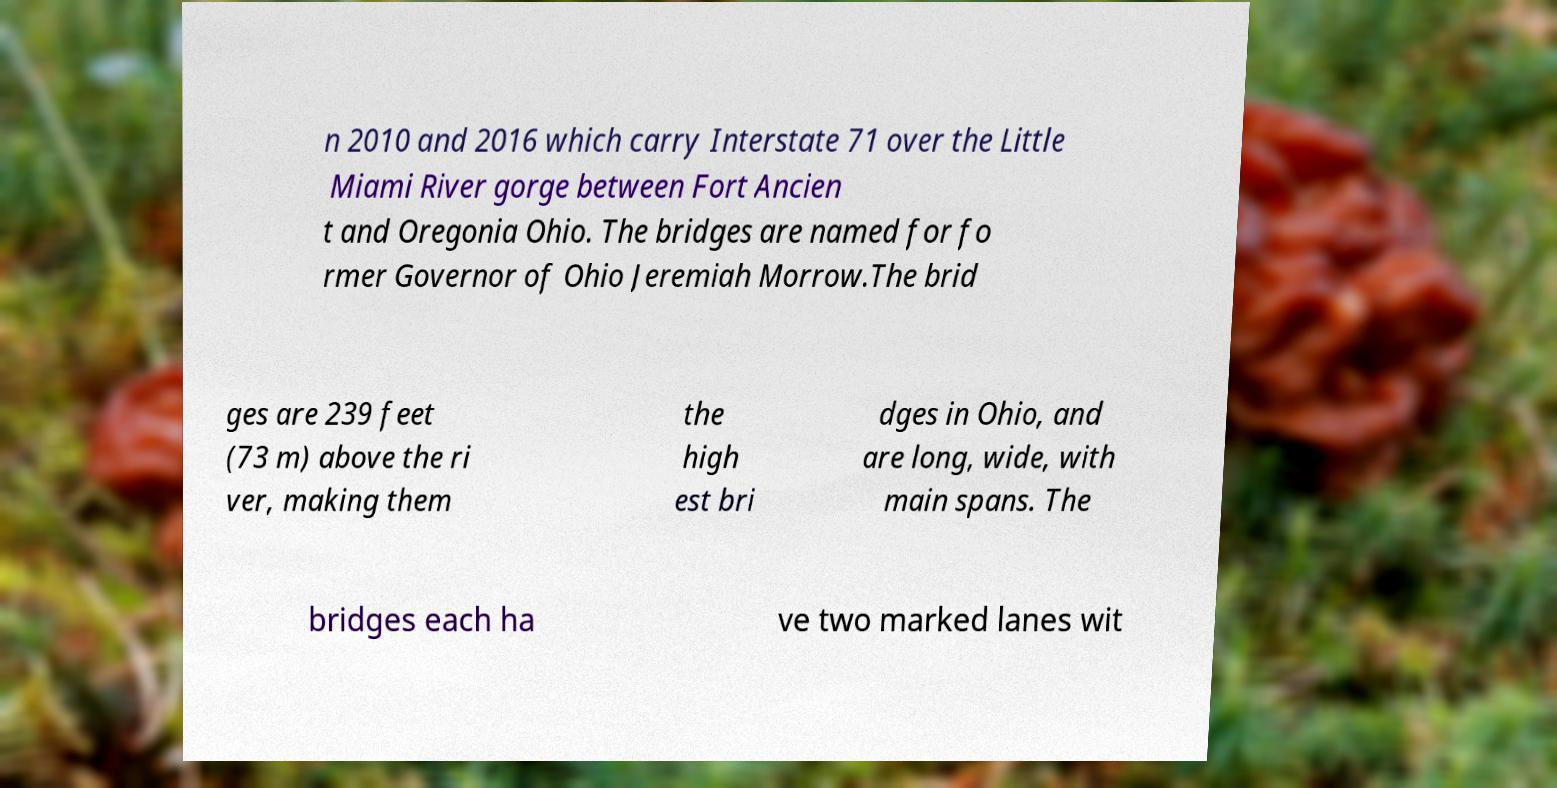Please identify and transcribe the text found in this image. n 2010 and 2016 which carry Interstate 71 over the Little Miami River gorge between Fort Ancien t and Oregonia Ohio. The bridges are named for fo rmer Governor of Ohio Jeremiah Morrow.The brid ges are 239 feet (73 m) above the ri ver, making them the high est bri dges in Ohio, and are long, wide, with main spans. The bridges each ha ve two marked lanes wit 